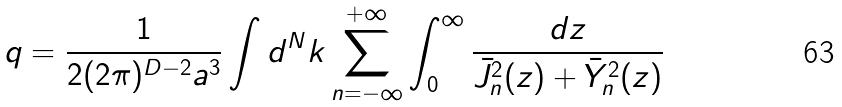Convert formula to latex. <formula><loc_0><loc_0><loc_500><loc_500>q = \frac { 1 } { 2 ( 2 \pi ) ^ { D - 2 } a ^ { 3 } } \int d ^ { N } { k } \sum _ { n = - \infty } ^ { + \infty } \int _ { 0 } ^ { \infty } \frac { d z } { \bar { J } _ { n } ^ { 2 } ( z ) + \bar { Y } _ { n } ^ { 2 } ( z ) }</formula> 